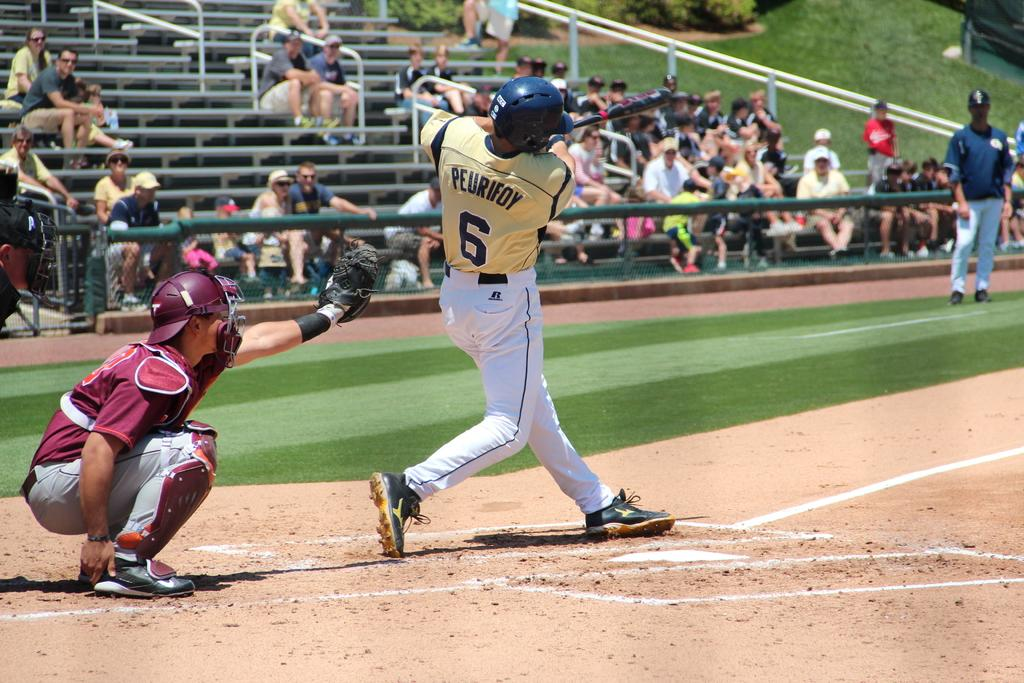<image>
Offer a succinct explanation of the picture presented. number 6 peurifoy swings at a pitch in front of sparse crowd 